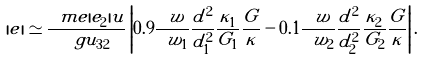Convert formula to latex. <formula><loc_0><loc_0><loc_500><loc_500>| e | \simeq \frac { \ m e | e _ { 2 } | u } { \ g u _ { 3 2 } } \left | 0 . 9 \frac { \ w } { \ w _ { 1 } } \frac { d ^ { 2 } } { d ^ { 2 } _ { 1 } } \frac { \kappa _ { 1 } } { G _ { 1 } } \frac { G } { \kappa } - 0 . 1 \frac { \ w } { \ w _ { 2 } } \frac { d ^ { 2 } } { d ^ { 2 } _ { 2 } } \frac { \kappa _ { 2 } } { G _ { 2 } } \frac { G } { \kappa } \right | .</formula> 